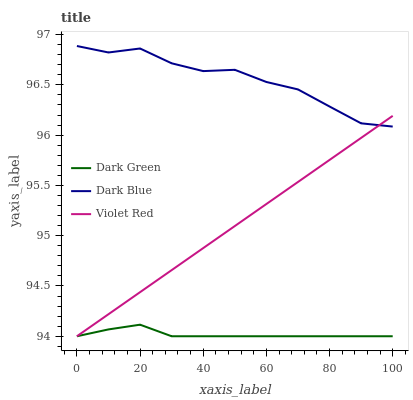Does Dark Green have the minimum area under the curve?
Answer yes or no. Yes. Does Dark Blue have the maximum area under the curve?
Answer yes or no. Yes. Does Violet Red have the minimum area under the curve?
Answer yes or no. No. Does Violet Red have the maximum area under the curve?
Answer yes or no. No. Is Violet Red the smoothest?
Answer yes or no. Yes. Is Dark Blue the roughest?
Answer yes or no. Yes. Is Dark Green the smoothest?
Answer yes or no. No. Is Dark Green the roughest?
Answer yes or no. No. Does Violet Red have the lowest value?
Answer yes or no. Yes. Does Dark Blue have the highest value?
Answer yes or no. Yes. Does Violet Red have the highest value?
Answer yes or no. No. Is Dark Green less than Dark Blue?
Answer yes or no. Yes. Is Dark Blue greater than Dark Green?
Answer yes or no. Yes. Does Violet Red intersect Dark Blue?
Answer yes or no. Yes. Is Violet Red less than Dark Blue?
Answer yes or no. No. Is Violet Red greater than Dark Blue?
Answer yes or no. No. Does Dark Green intersect Dark Blue?
Answer yes or no. No. 